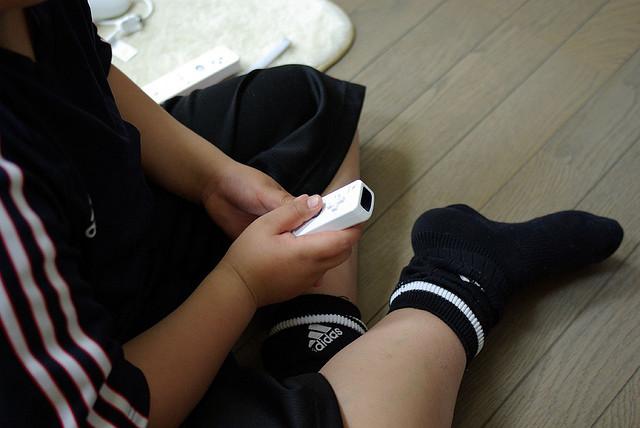What color is the stripe on the sock?
Be succinct. White. What brand are the little boy's socks?
Short answer required. Adidas. Is this casual clothing?
Quick response, please. Yes. How artistic is this picture?
Short answer required. Not very. What article of clothing is that?
Quick response, please. Sock. Are these winter or fall clothing?
Write a very short answer. Fall. What is the boy holding?
Concise answer only. Wii remote. What are those called on the feet?
Be succinct. Socks. 